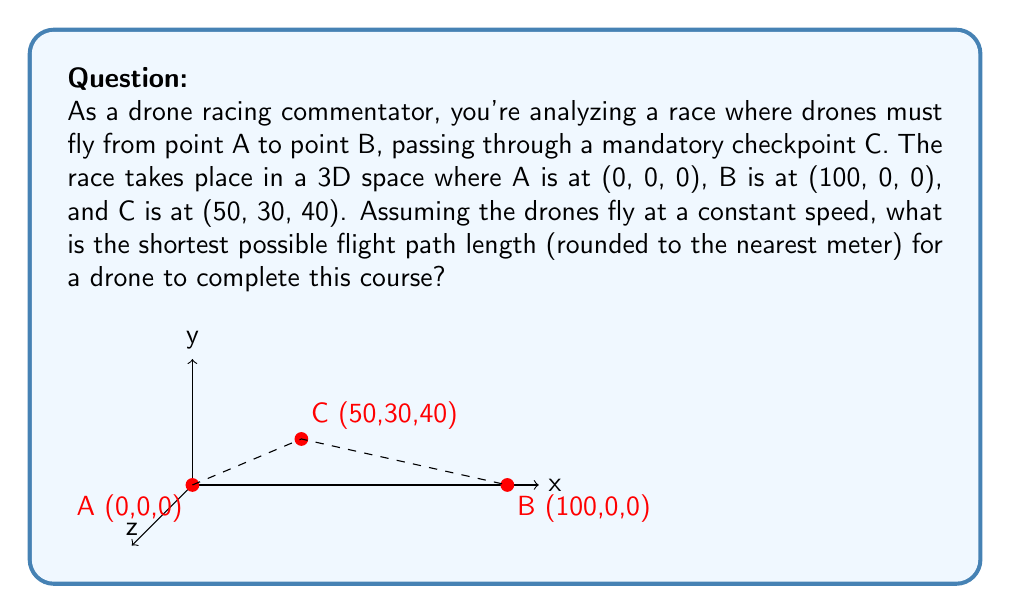Show me your answer to this math problem. To solve this problem, we need to use the concept of 3D distance and the fact that the shortest path between two points is a straight line. The optimal trajectory will be two straight line segments: A to C, and C to B.

Step 1: Calculate the distance from A to C
We can use the 3D distance formula:
$$d_{AC} = \sqrt{(x_2-x_1)^2 + (y_2-y_1)^2 + (z_2-z_1)^2}$$
$$d_{AC} = \sqrt{(50-0)^2 + (30-0)^2 + (40-0)^2}$$
$$d_{AC} = \sqrt{2500 + 900 + 1600} = \sqrt{5000} \approx 70.71$$

Step 2: Calculate the distance from C to B
Using the same formula:
$$d_{CB} = \sqrt{(100-50)^2 + (0-30)^2 + (0-40)^2}$$
$$d_{CB} = \sqrt{2500 + 900 + 1600} = \sqrt{5000} \approx 70.71$$

Step 3: Sum the two distances
Total distance = $d_{AC} + d_{CB} \approx 70.71 + 70.71 = 141.42$

Step 4: Round to the nearest meter
141.42 rounds to 141 meters.

This trajectory is optimal because any other path passing through C would be longer than the sum of the two straight line segments.
Answer: 141 meters 